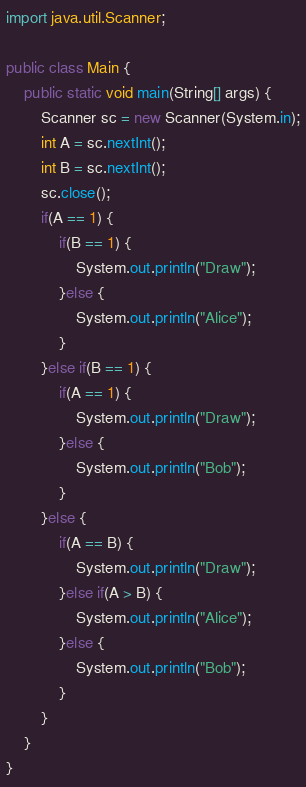Convert code to text. <code><loc_0><loc_0><loc_500><loc_500><_Java_>import java.util.Scanner;

public class Main {
	public static void main(String[] args) {
		Scanner sc = new Scanner(System.in);
		int A = sc.nextInt();
		int B = sc.nextInt();
		sc.close();
		if(A == 1) {
			if(B == 1) {
				System.out.println("Draw");
			}else {
				System.out.println("Alice");
			}
		}else if(B == 1) {
			if(A == 1) {
				System.out.println("Draw");
			}else {
				System.out.println("Bob");
			}
		}else {
			if(A == B) {
				System.out.println("Draw");
			}else if(A > B) {
				System.out.println("Alice");
			}else {
				System.out.println("Bob");
			}
		}
	}
}
</code> 